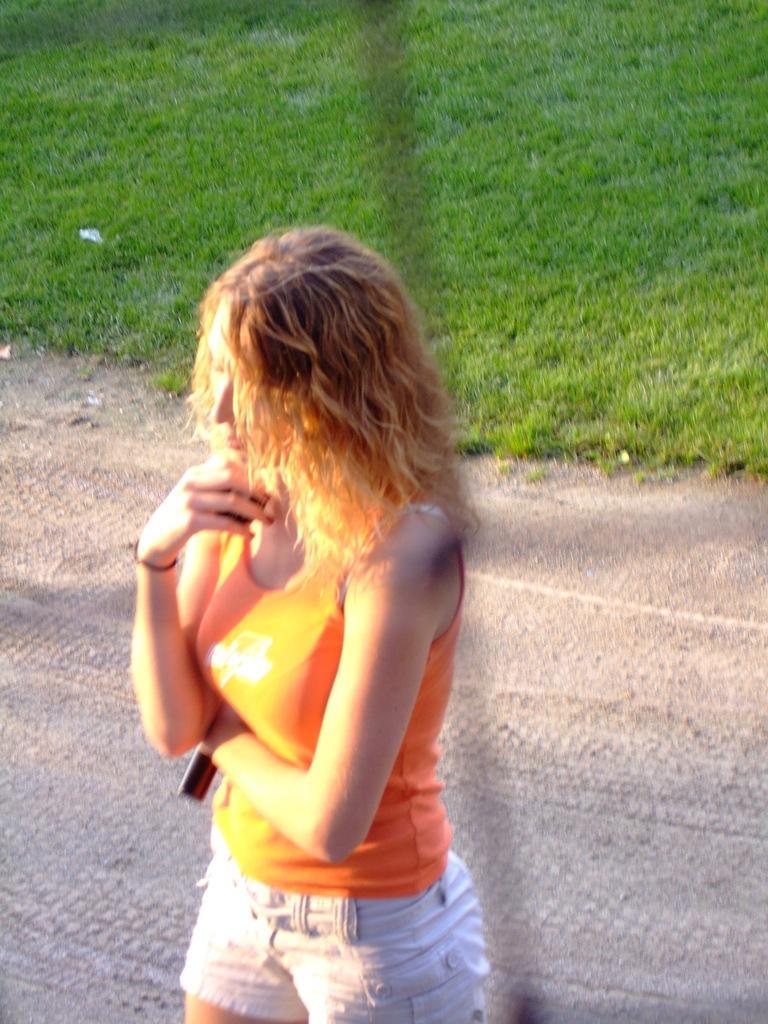In one or two sentences, can you explain what this image depicts? This woman is holding an object and standing. Background there is a grass. 